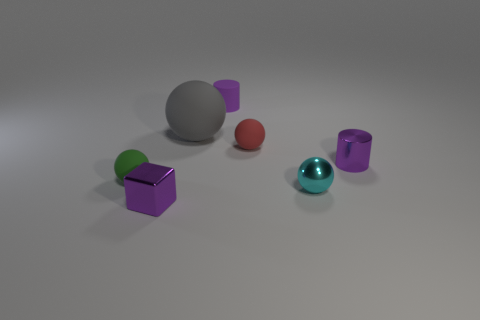Subtract all gray balls. How many balls are left? 3 Subtract all red spheres. How many spheres are left? 3 Add 1 large rubber spheres. How many objects exist? 8 Subtract all balls. How many objects are left? 3 Subtract 1 blocks. How many blocks are left? 0 Add 3 purple shiny spheres. How many purple shiny spheres exist? 3 Subtract 0 purple balls. How many objects are left? 7 Subtract all yellow spheres. Subtract all yellow cubes. How many spheres are left? 4 Subtract all small cyan shiny things. Subtract all tiny metallic balls. How many objects are left? 5 Add 2 tiny matte objects. How many tiny matte objects are left? 5 